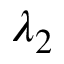Convert formula to latex. <formula><loc_0><loc_0><loc_500><loc_500>\lambda _ { 2 }</formula> 